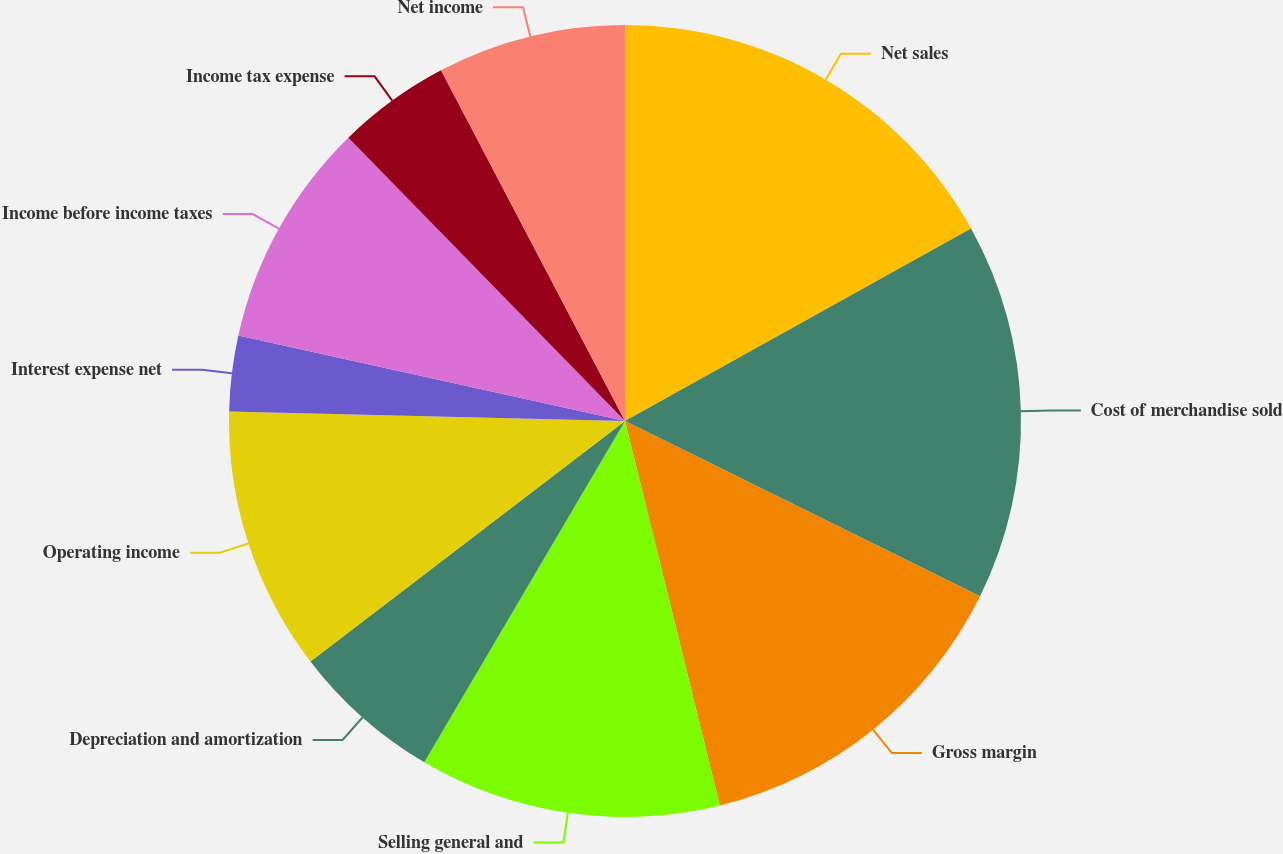Convert chart to OTSL. <chart><loc_0><loc_0><loc_500><loc_500><pie_chart><fcel>Net sales<fcel>Cost of merchandise sold<fcel>Gross margin<fcel>Selling general and<fcel>Depreciation and amortization<fcel>Operating income<fcel>Interest expense net<fcel>Income before income taxes<fcel>Income tax expense<fcel>Net income<nl><fcel>16.92%<fcel>15.38%<fcel>13.85%<fcel>12.31%<fcel>6.15%<fcel>10.77%<fcel>3.08%<fcel>9.23%<fcel>4.62%<fcel>7.69%<nl></chart> 